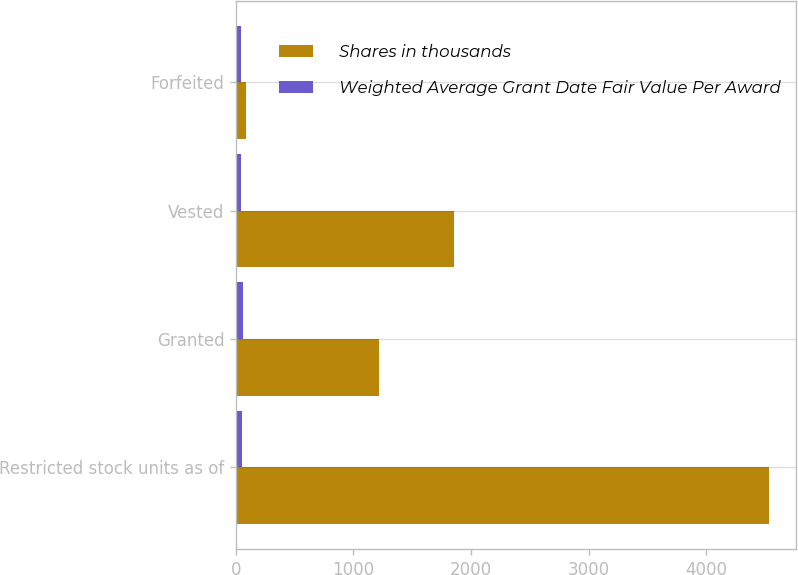Convert chart. <chart><loc_0><loc_0><loc_500><loc_500><stacked_bar_chart><ecel><fcel>Restricted stock units as of<fcel>Granted<fcel>Vested<fcel>Forfeited<nl><fcel>Shares in thousands<fcel>4539<fcel>1214<fcel>1854<fcel>89<nl><fcel>Weighted Average Grant Date Fair Value Per Award<fcel>48<fcel>59<fcel>41<fcel>45<nl></chart> 